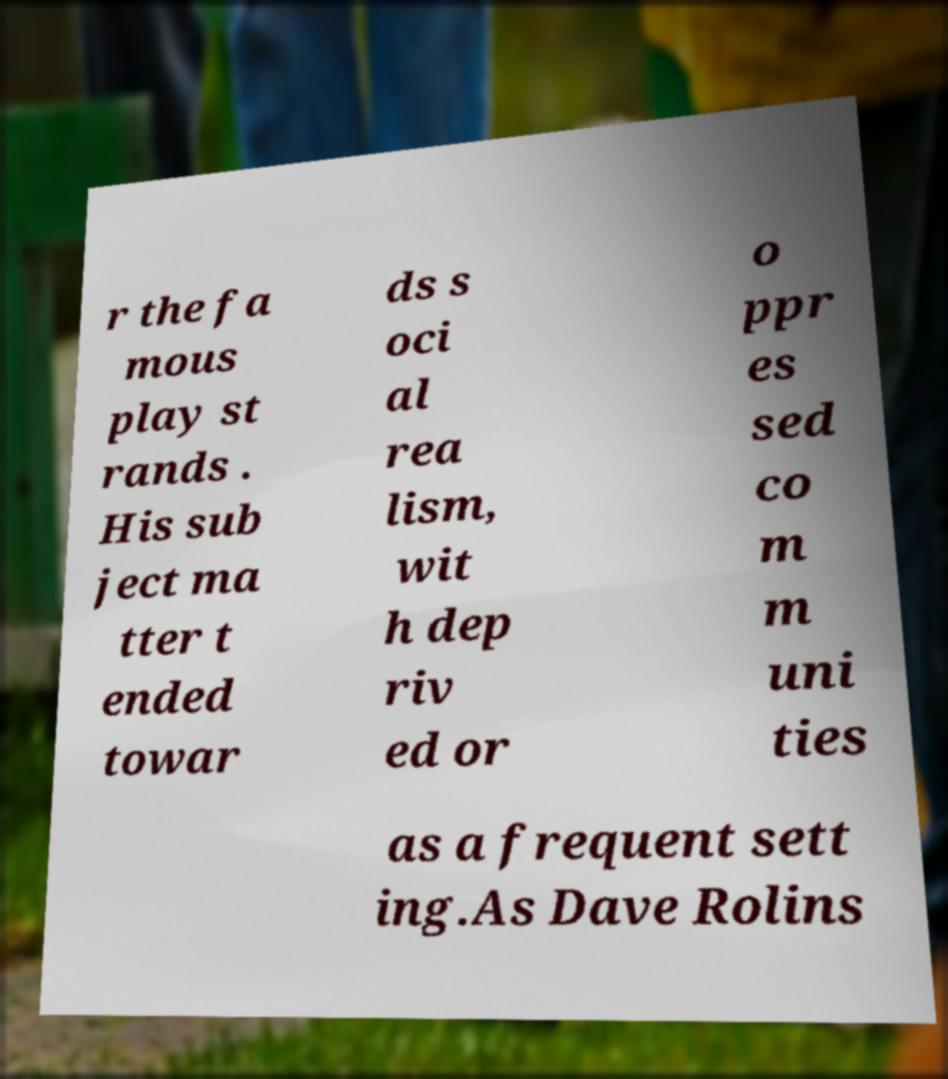Could you assist in decoding the text presented in this image and type it out clearly? r the fa mous play st rands . His sub ject ma tter t ended towar ds s oci al rea lism, wit h dep riv ed or o ppr es sed co m m uni ties as a frequent sett ing.As Dave Rolins 